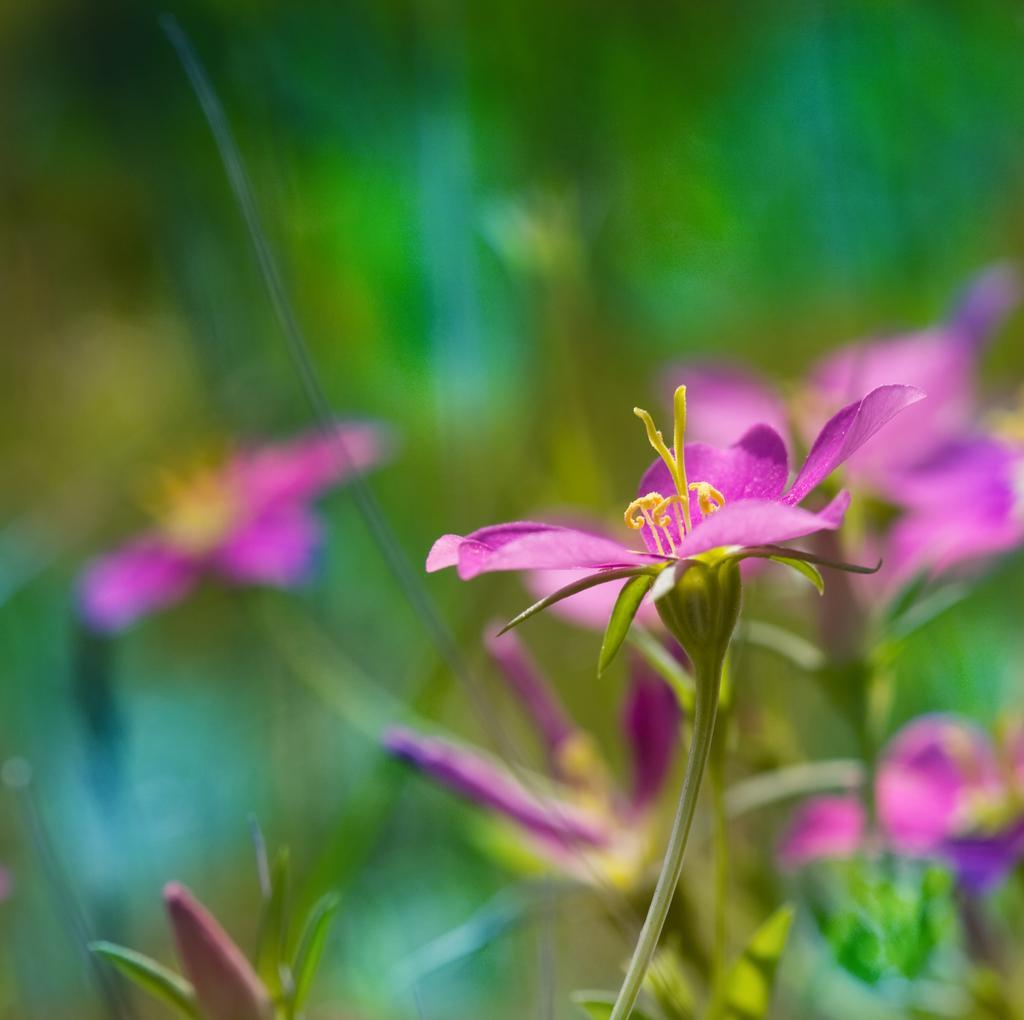Please provide a concise description of this image. In this image we can see group of flowers and some leaves. 